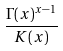<formula> <loc_0><loc_0><loc_500><loc_500>\frac { \Gamma ( x ) ^ { x - 1 } } { K ( x ) }</formula> 